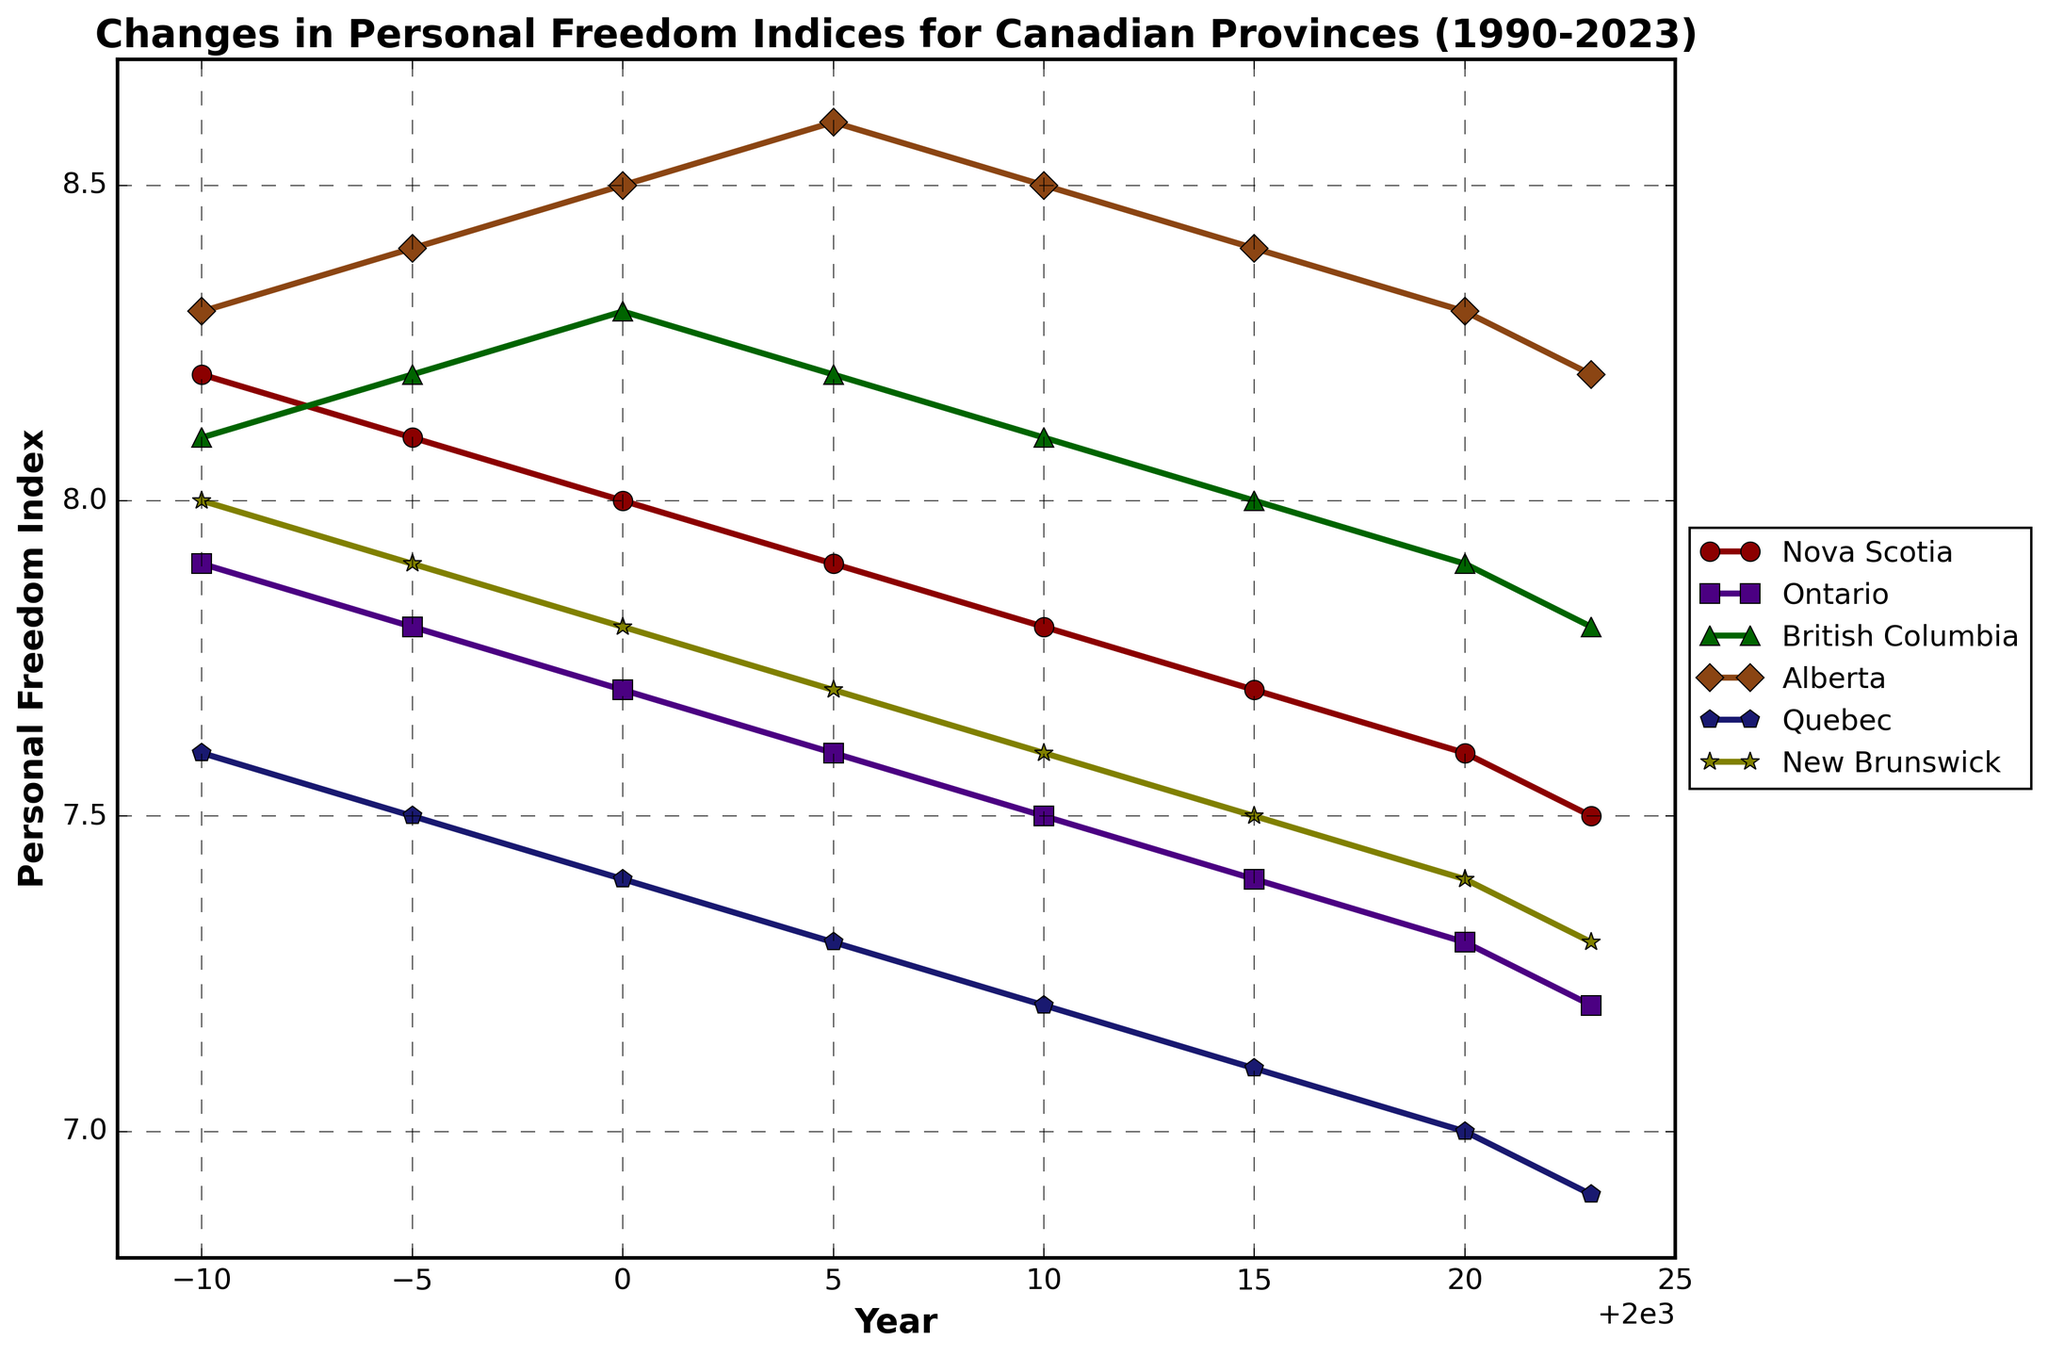What province had the highest personal freedom index in 2000? Check the values for each province in the year 2000 and find the highest. Alberta had an index of 8.5, which is the highest.
Answer: Alberta Which province shows a consistent decline in personal freedom index from 1990 to 2023? Check the trend lines of each province from 1990 to 2023. Nova Scotia exhibits a consistent decline from 8.2 in 1990 to 7.5 in 2023.
Answer: Nova Scotia Between which years did Ontario's personal freedom index decrease the most? Examine Ontario's index values and the years they represent. The largest drop is between 1995 (7.8) and 2000 (7.7).
Answer: 1995-2000 What is the average personal freedom index of British Columbia from 1990 to 2023? Sum the values of British Columbia from 1990 to 2023 and divide by the number of years. (8.1 + 8.2 + 8.3 + 8.2 + 8.1 + 8.0 + 7.9 + 7.8) / 8 = 8.08
Answer: 8.08 By how many points did Quebec's personal freedom index drop from 2005 to 2023? Subtract Quebec's index in 2023 from its index in 2005. 7.3 - 6.9 = 0.4.
Answer: 0.4 Which two provinces had the closest personal freedom indices in 2010? Compare the 2010 values for each province and find the smallest difference. Quebec (7.2) and New Brunswick (7.6) have the closest indices with a difference of 0.4.
Answer: Quebec and New Brunswick Does Alberta's index ever fall below Nova Scotia's from 1990 to 2023? Check each year's values for both provinces. Alberta's index is consistently higher than Nova Scotia's in all years.
Answer: No Which year did New Brunswick's personal freedom index drop below 7.5? Check New Brunswick's values over the years. It drops to 7.4 in 2020.
Answer: 2020 What is the median value of the personal freedom index for Quebec from 1990 to 2023? Arrange Quebec's indices in order and find the middle value. (6.9, 7.0, 7.1, 7.2, 7.3, 7.4, 7.5, 7.6), median is the average of 7.2 and 7.3, which is 7.25.
Answer: 7.25 Between 1990 and 2023, which province had the smallest range in personal freedom index? Calculate the range (max - min) for each province. New Brunswick has the smallest range: 8.0 - 7.3 = 0.7.
Answer: New Brunswick 